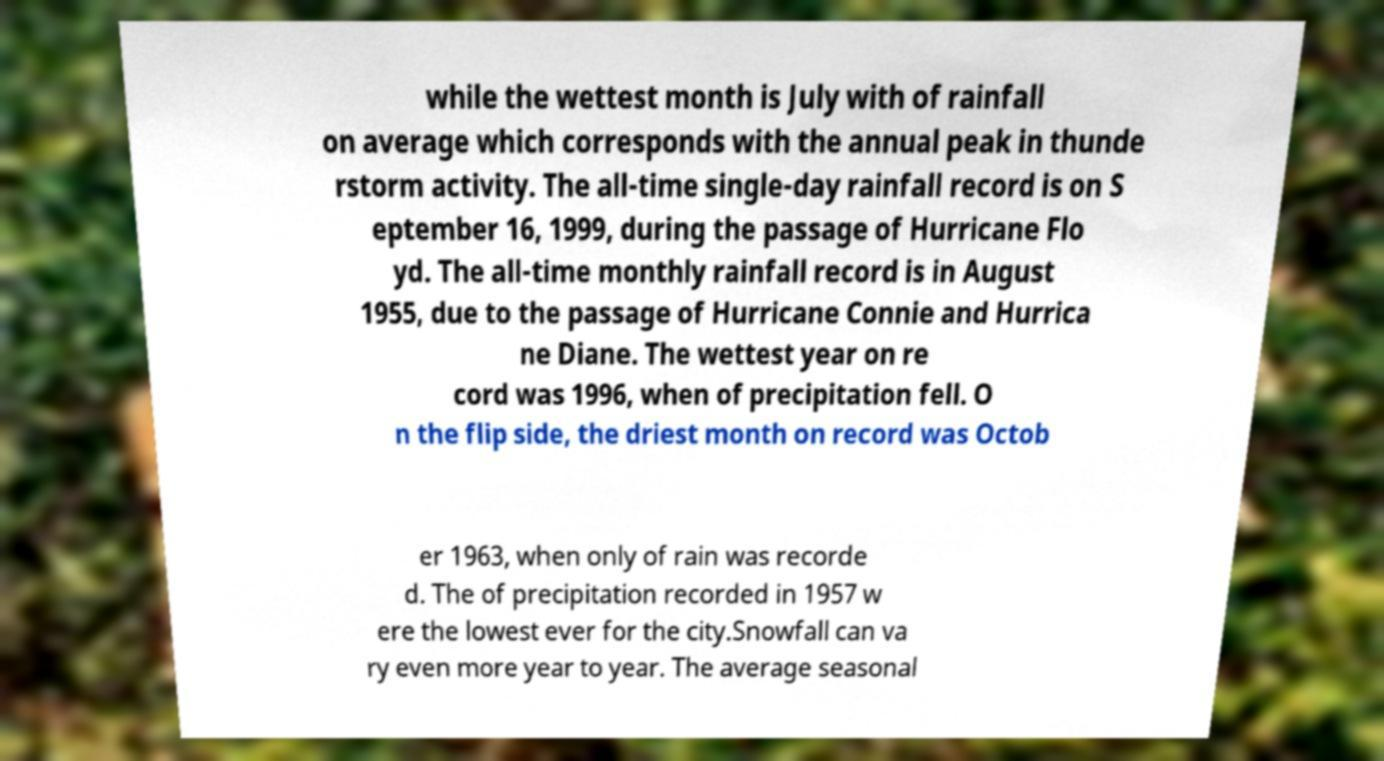There's text embedded in this image that I need extracted. Can you transcribe it verbatim? while the wettest month is July with of rainfall on average which corresponds with the annual peak in thunde rstorm activity. The all-time single-day rainfall record is on S eptember 16, 1999, during the passage of Hurricane Flo yd. The all-time monthly rainfall record is in August 1955, due to the passage of Hurricane Connie and Hurrica ne Diane. The wettest year on re cord was 1996, when of precipitation fell. O n the flip side, the driest month on record was Octob er 1963, when only of rain was recorde d. The of precipitation recorded in 1957 w ere the lowest ever for the city.Snowfall can va ry even more year to year. The average seasonal 